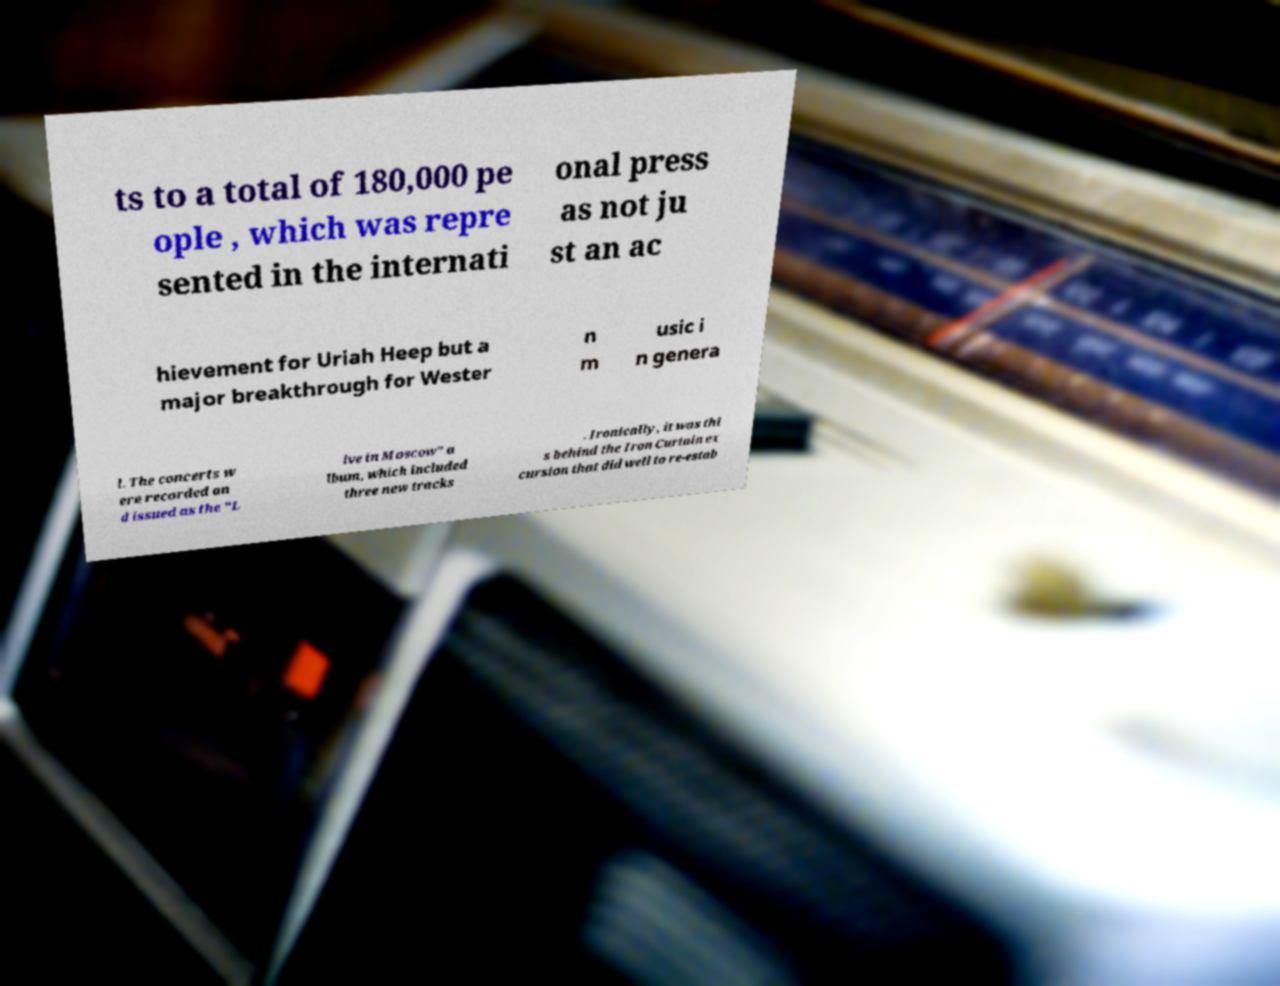Could you extract and type out the text from this image? ts to a total of 180,000 pe ople , which was repre sented in the internati onal press as not ju st an ac hievement for Uriah Heep but a major breakthrough for Wester n m usic i n genera l. The concerts w ere recorded an d issued as the "L ive in Moscow" a lbum, which included three new tracks . Ironically, it was thi s behind the Iron Curtain ex cursion that did well to re-estab 